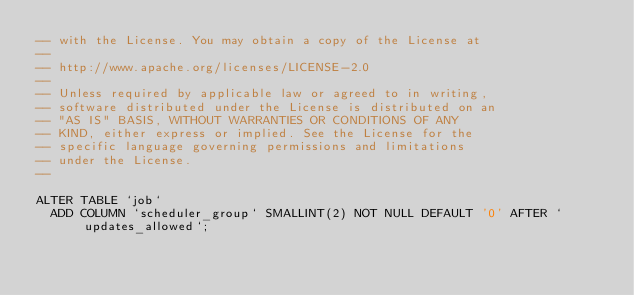Convert code to text. <code><loc_0><loc_0><loc_500><loc_500><_SQL_>-- with the License. You may obtain a copy of the License at
--
-- http://www.apache.org/licenses/LICENSE-2.0
--
-- Unless required by applicable law or agreed to in writing,
-- software distributed under the License is distributed on an
-- "AS IS" BASIS, WITHOUT WARRANTIES OR CONDITIONS OF ANY
-- KIND, either express or implied. See the License for the
-- specific language governing permissions and limitations
-- under the License.
--

ALTER TABLE `job`
	ADD COLUMN `scheduler_group` SMALLINT(2) NOT NULL DEFAULT '0' AFTER `updates_allowed`;</code> 